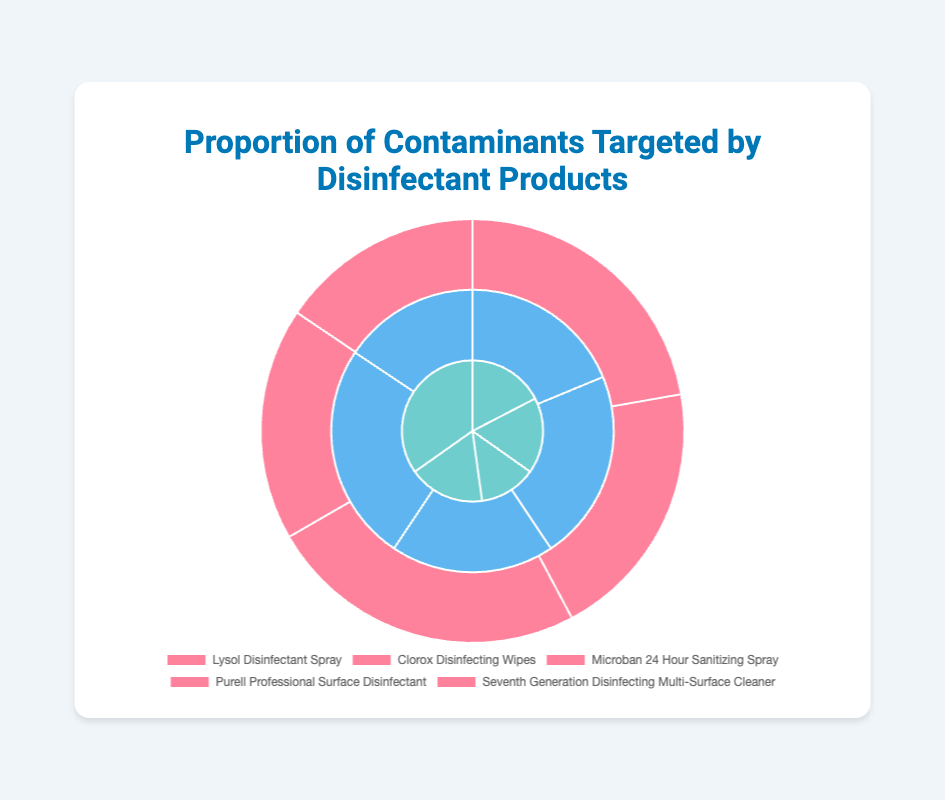Which disinfectant product targets bacteria the most? To determine which disinfectant product targets bacteria the most, look for the product with the highest percentage targeting bacteria. According to the data, "Microban 24 Hour Sanitizing Spray" targets 55% of bacteria, which is the highest among all the disinfectants listed.
Answer: Microban 24 Hour Sanitizing Spray Which disinfectant product targets fungi the most? To identify the product targeting fungi the most, look for the highest percentage allocated to fungi. According to the data, "Seventh Generation Disinfecting Multi-Surface Cleaner" targets 40% of fungi, the highest percentage among the listed products.
Answer: Seventh Generation Disinfecting Multi-Surface Cleaner Calculate the average proportion of viruses targeted by the disinfectant products. First, sum up the percentages of viruses targeted by each disinfectant: 30 + 35 + 30 + 40 + 25 = 160. Then, divide by the number of products: 160 / 5 = 32.
Answer: 32 Which disinfectant product has the least focus on viruses? To determine the least focus on viruses, look for the product with the lowest percentage for viruses. "Seventh Generation Disinfecting Multi-Surface Cleaner" targets 25% of viruses, which is the lowest among the listed products.
Answer: Seventh Generation Disinfecting Multi-Surface Cleaner Compare the proportions of bacteria targeted by Lysol Disinfectant Spray and Clorox Disinfecting Wipes. Which one targets more? By comparing the proportions, Lysol Disinfectant Spray targets 50% bacteria while Clorox Disinfecting Wipes targets 45% bacteria.
Answer: Lysol Disinfectant Spray Sum the proportions of bacteria and fungi targeted by Purell Professional Surface Disinfectant. Add the proportion of bacteria and fungi for Purell: 40% bacteria + 20% fungi = 60%.
Answer: 60 How do the fungal targeting proportions of Microban 24 Hour Sanitizing Spray and Clorox Disinfecting Wipes compare? Microban 24 Hour Sanitizing Spray targets 15% fungi, while Clorox Disinfecting Wipes targets 20% fungi.
Answer: Clorox Disinfecting Wipes targets more Which two disinfectant products have the same fungal targeting proportion, and what is that proportion? Observe the data to find Lysol Disinfectant Spray and Clorox Disinfecting Wipes both target fungi at 20%.
Answer: Lysol Disinfectant Spray and Clorox Disinfecting Wipes; 20% If a disinfectant product targets an equal proportion of bacteria and viruses, which product is it? Check the data for a product with equal percentages for bacteria and viruses. Purell Professional Surface Disinfectant targets 40% bacteria and 40% viruses.
Answer: Purell Professional Surface Disinfectant Which disinfectant targets bacteria the least? To find the product that targets bacteria the least, look for the lowest percentage among the bacteria values. "Seventh Generation Disinfecting Multi-Surface Cleaner" targets 35% bacteria, the lowest percentage.
Answer: Seventh Generation Disinfecting Multi-Surface Cleaner 